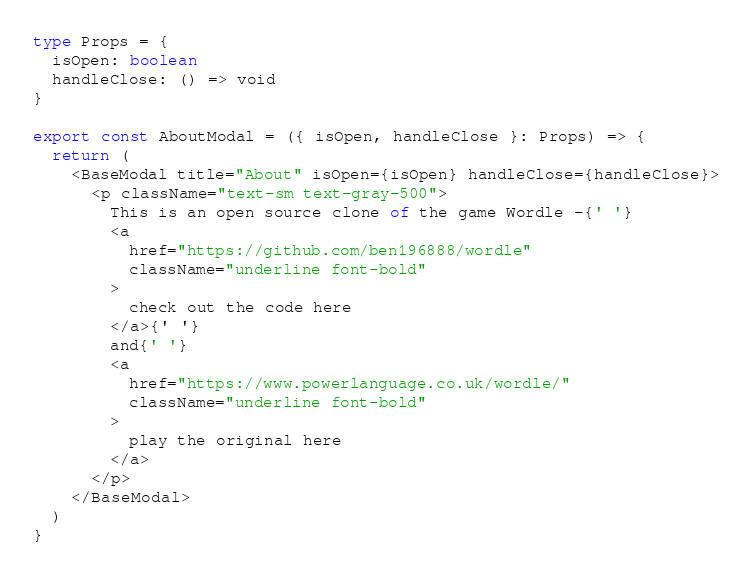Convert code to text. <code><loc_0><loc_0><loc_500><loc_500><_TypeScript_>type Props = {
  isOpen: boolean
  handleClose: () => void
}

export const AboutModal = ({ isOpen, handleClose }: Props) => {
  return (
    <BaseModal title="About" isOpen={isOpen} handleClose={handleClose}>
      <p className="text-sm text-gray-500">
        This is an open source clone of the game Wordle -{' '}
        <a
          href="https://github.com/ben196888/wordle"
          className="underline font-bold"
        >
          check out the code here
        </a>{' '}
        and{' '}
        <a
          href="https://www.powerlanguage.co.uk/wordle/"
          className="underline font-bold"
        >
          play the original here
        </a>
      </p>
    </BaseModal>
  )
}
</code> 